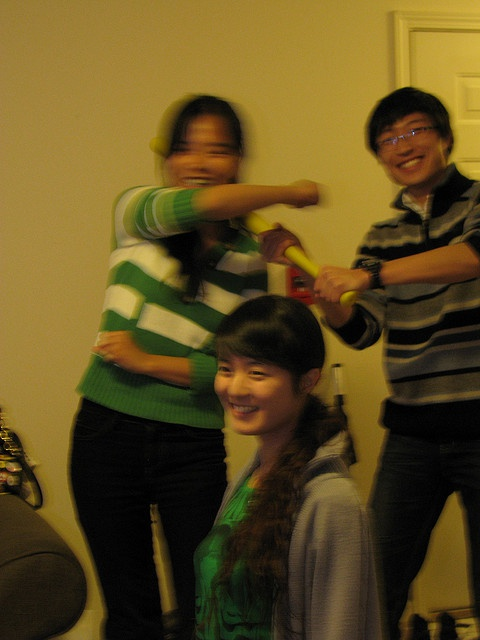Describe the objects in this image and their specific colors. I can see people in olive, black, and darkgreen tones, people in olive, black, maroon, and brown tones, people in olive, black, and maroon tones, chair in olive and black tones, and baseball bat in olive and maroon tones in this image. 